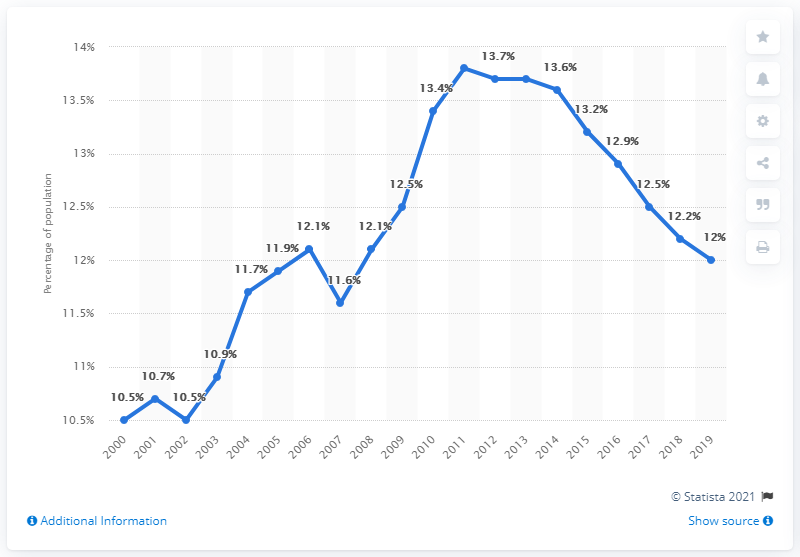Mention a couple of crucial points in this snapshot. In 2011, Pennsylvania experienced the greatest level of poverty. The average poverty rate from 2000 to 2004 was 10.86. 